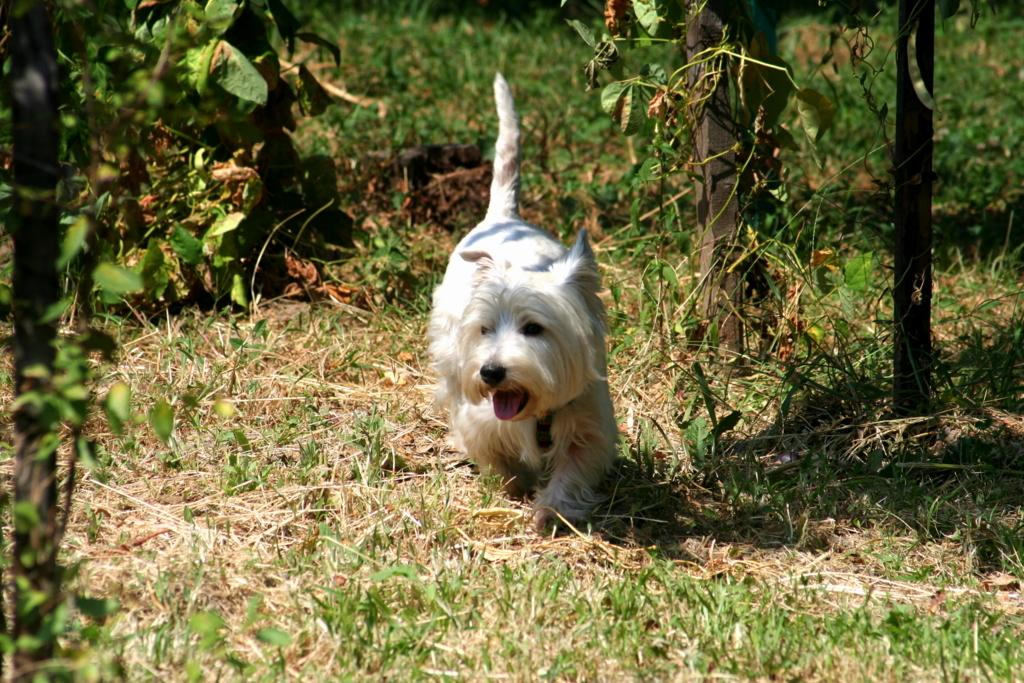What type of animal is in the image? There is a white dog in the image. What is the dog standing on? The dog is on a grass surface. What can be seen around the dog? There are plants around the dog. What is the distance between the dog and its mom in the image? There is no mention of the dog's mom in the image, so we cannot determine the distance between them. 